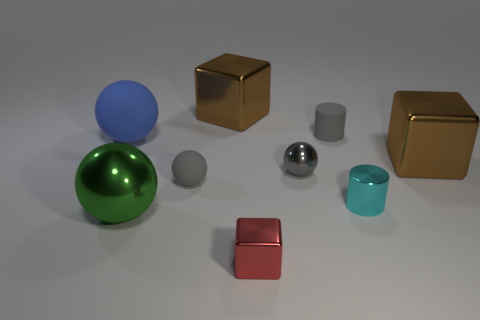Is there a small thing that has the same color as the metal cylinder?
Provide a short and direct response. No. Does the object that is in front of the big green sphere have the same shape as the tiny rubber object in front of the small rubber cylinder?
Your response must be concise. No. There is a matte ball that is the same color as the small matte cylinder; what is its size?
Provide a short and direct response. Small. What number of other objects are there of the same size as the cyan cylinder?
Ensure brevity in your answer.  4. Is the color of the tiny shiny ball the same as the metal thing that is to the right of the cyan object?
Your answer should be very brief. No. Are there fewer cyan cylinders to the left of the small red block than large brown blocks on the left side of the small shiny cylinder?
Your answer should be very brief. Yes. The big thing that is both to the left of the tiny gray matte sphere and behind the small gray matte sphere is what color?
Offer a very short reply. Blue. There is a matte cylinder; is its size the same as the matte thing in front of the large blue ball?
Give a very brief answer. Yes. There is a thing that is in front of the large green sphere; what is its shape?
Provide a short and direct response. Cube. Is there anything else that is made of the same material as the big blue sphere?
Give a very brief answer. Yes. 